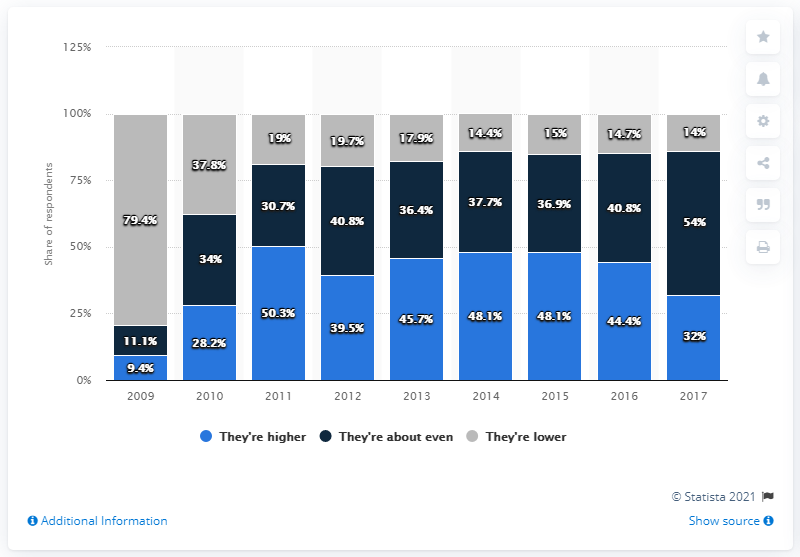Draw attention to some important aspects in this diagram. Travel Leaders Group started offering travel bookings in 2009. 